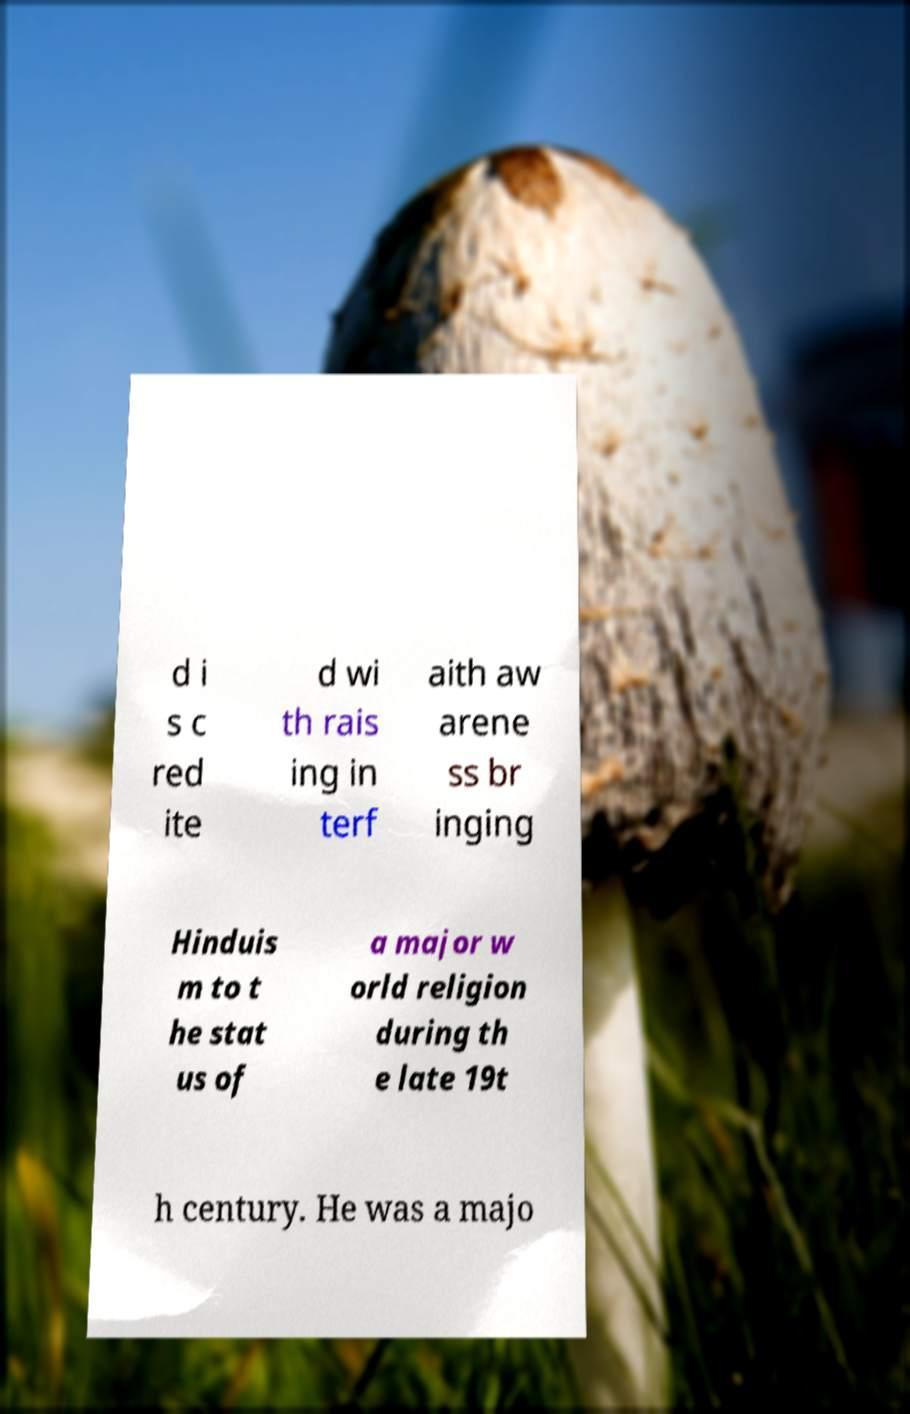Please identify and transcribe the text found in this image. d i s c red ite d wi th rais ing in terf aith aw arene ss br inging Hinduis m to t he stat us of a major w orld religion during th e late 19t h century. He was a majo 